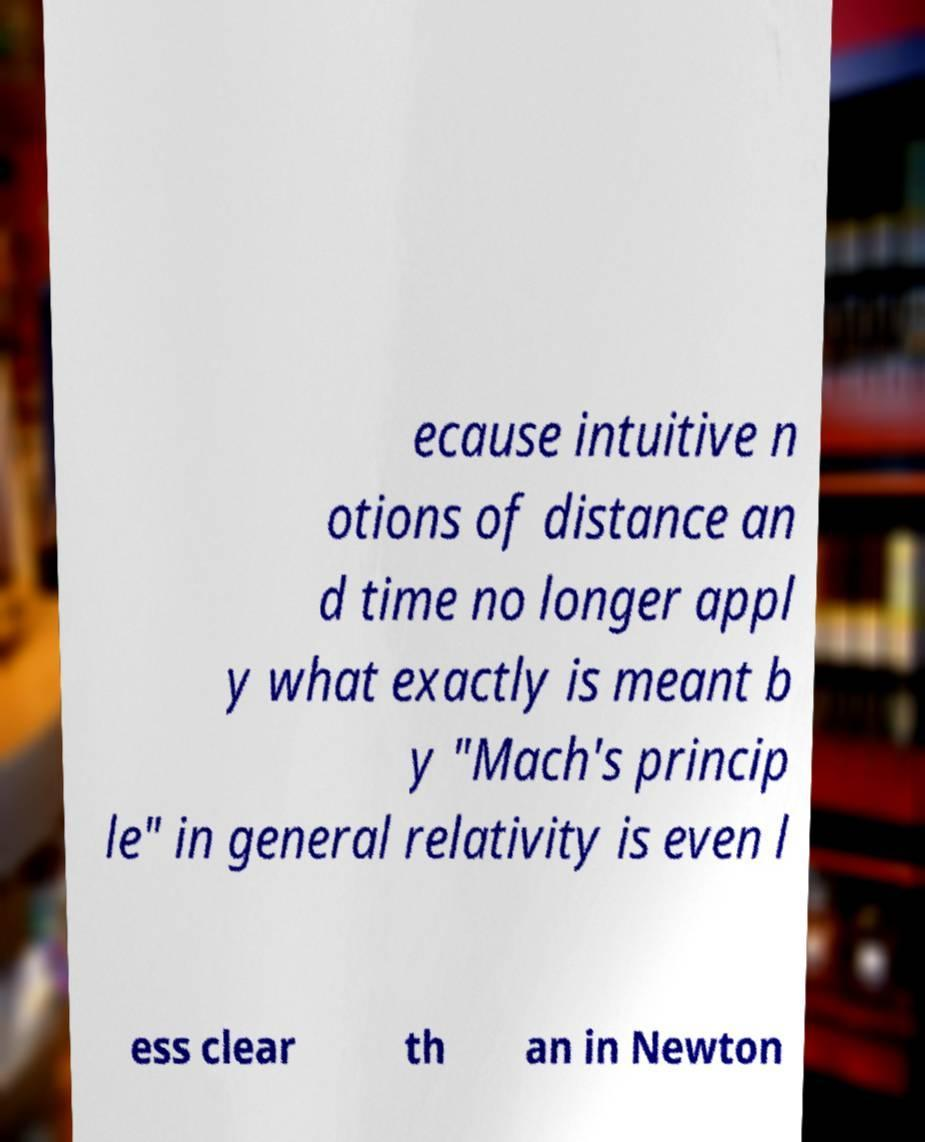I need the written content from this picture converted into text. Can you do that? ecause intuitive n otions of distance an d time no longer appl y what exactly is meant b y "Mach's princip le" in general relativity is even l ess clear th an in Newton 